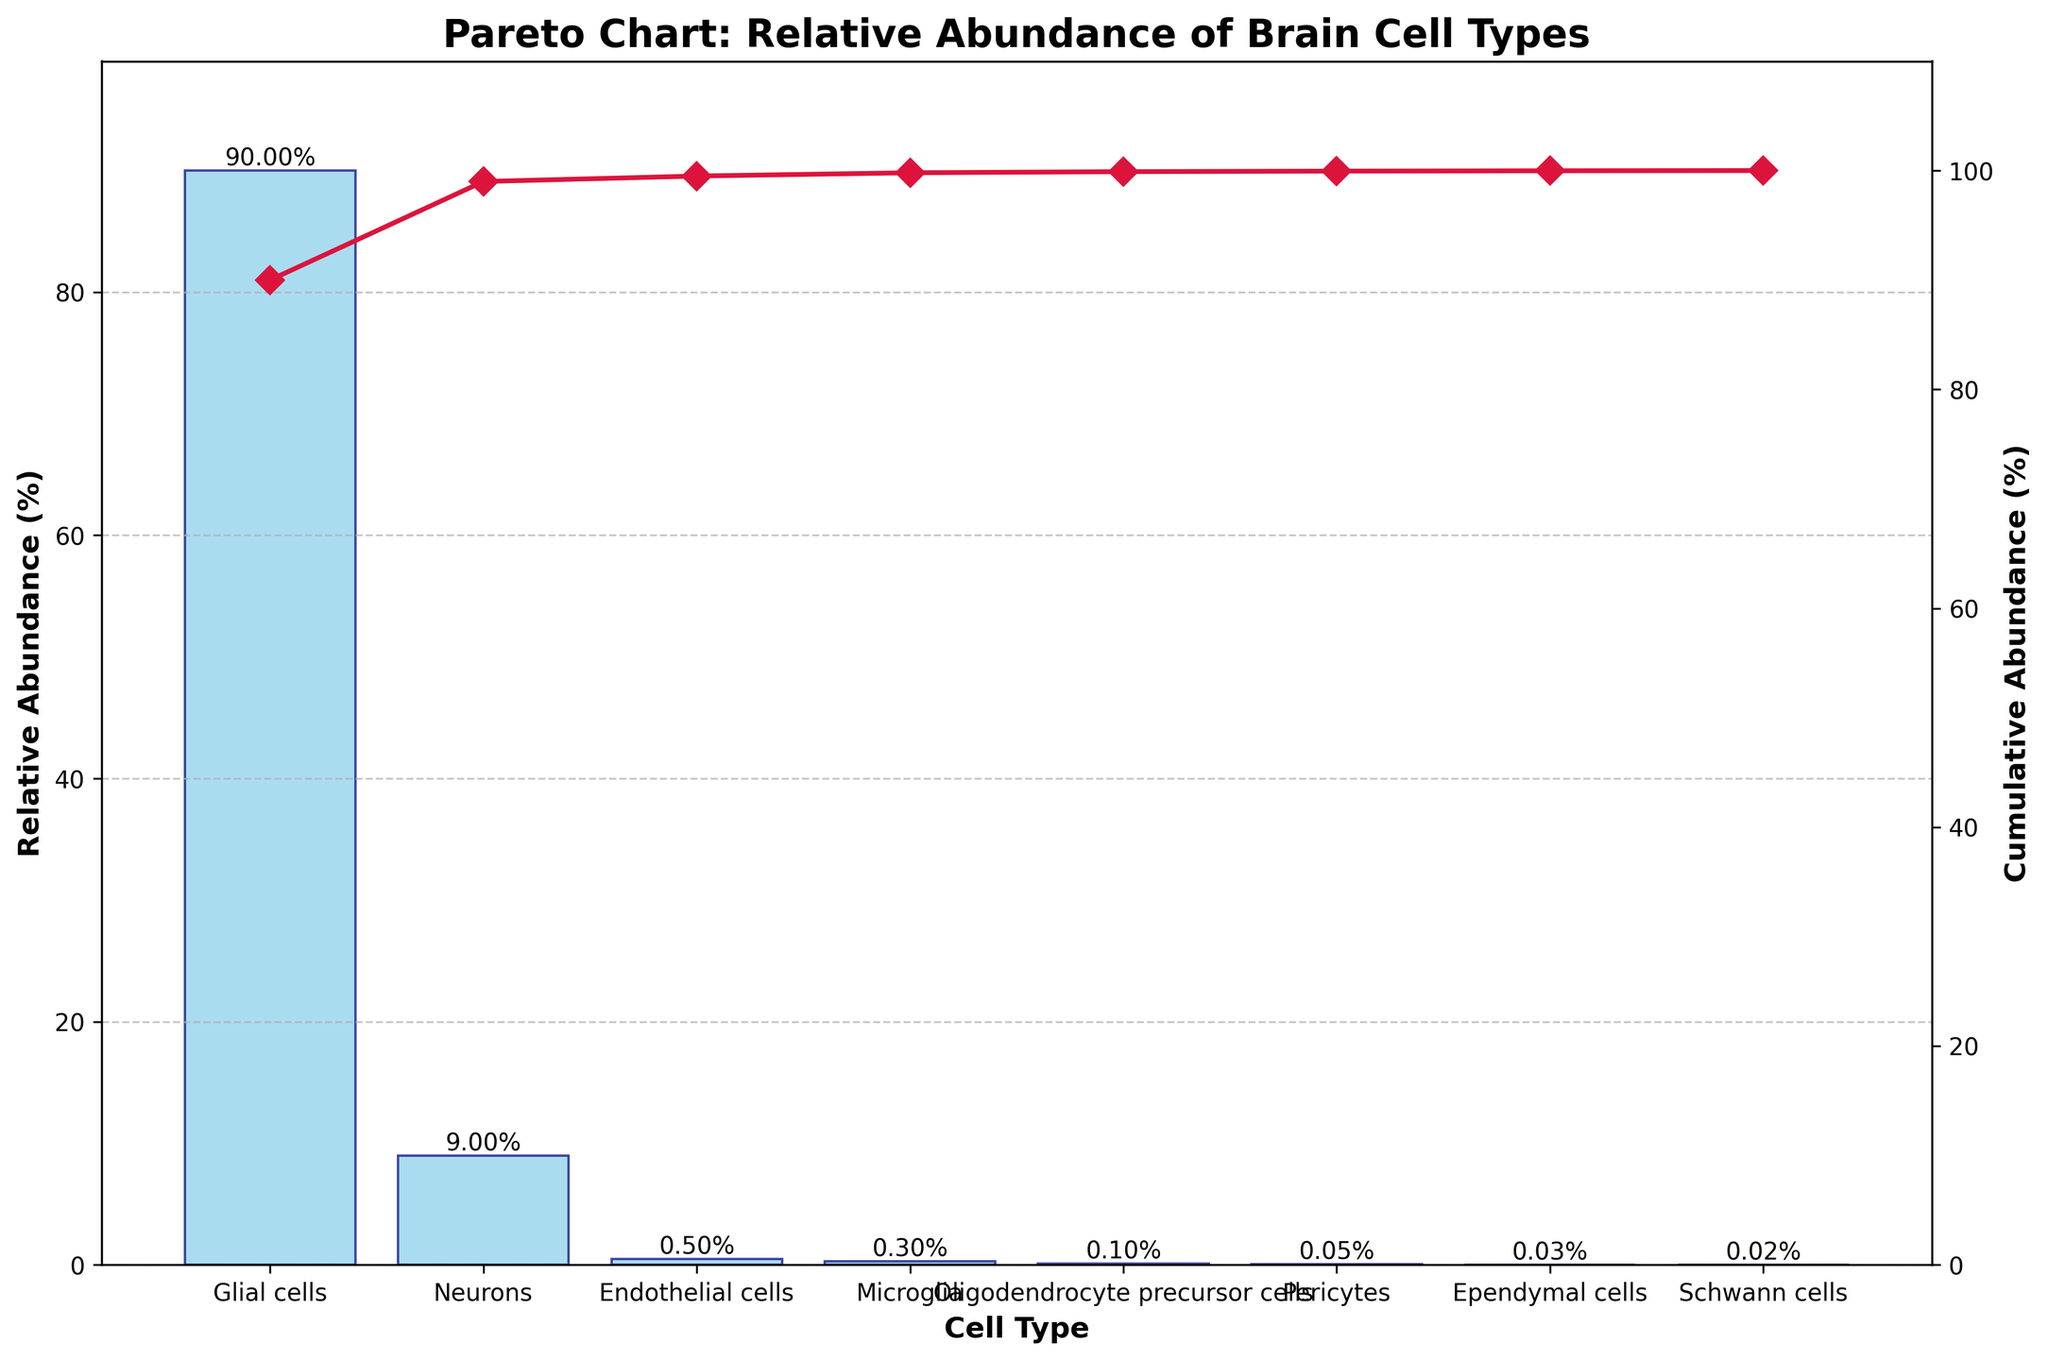What is the title of the chart? The title of the chart is displayed prominently at the top and reads "Pareto Chart: Relative Abundance of Brain Cell Types."
Answer: Pareto Chart: Relative Abundance of Brain Cell Types Which cell type is the most abundant in the brain? The most abundant cell type is represented by the tallest bar in the chart, which corresponds to "Glial cells". Their relative abundance is 90%.
Answer: Glial cells What is the relative abundance of neurons? The bar for "Neurons" is labeled with the relative abundance value at the top. It shows that neurons have a relative abundance of 9%.
Answer: 9% What is the sum of the relative abundances of Microglia and Oligodendrocyte precursor cells? The chart shows that Microglia have a relative abundance of 0.3% and Oligodendrocyte precursor cells have 0.1%. Adding these two values results in 0.4%.
Answer: 0.4% How many cell types have a relative abundance below 1%? By examining the chart, we can see that there are six cell types with bars below the 1% value: Endothelial cells, Microglia, Oligodendrocyte precursor cells, Pericytes, Ependymal cells, and Schwann cells.
Answer: Six Compare the relative abundances of Endothelial cells and Ependymal cells. Which one is higher? The chart shows that Endothelial cells have a relative abundance of 0.5%, while Ependymal cells have 0.03%. Therefore, Endothelial cells have a higher relative abundance.
Answer: Endothelial cells What is the cumulative abundance threshold reached after adding the Glial cells and Neurons? The cumulative line plotted on the secondary axis shows the cumulative percentages. Adding Glial cells (90%) and Neurons (9%) results in 99%, which matches the cumulative line at the second data point.
Answer: 99% How much more abundant are Glial cells compared to Schwann cells? Glial cells have a relative abundance of 90%, while Schwann cells have 0.02%. The difference is 90% - 0.02% = 89.98%, so Glial cells are 89.98% more abundant.
Answer: 89.98% What is the combined relative abundance of Pericytes and Ependymal cells? The chart shows the relative abundances of Pericytes (0.05%) and Ependymal cells (0.03%). Adding these gives a combined relative abundance of 0.08%.
Answer: 0.08% What do the x-axis and y-axis represent in the chart? The x-axis represents different cell types in the brain, while the left y-axis corresponds to the relative abundance in percentage, and the right y-axis measures the cumulative abundance in percentage.
Answer: Cell types (x-axis), relative abundance (left y-axis), cumulative abundance (right y-axis) 